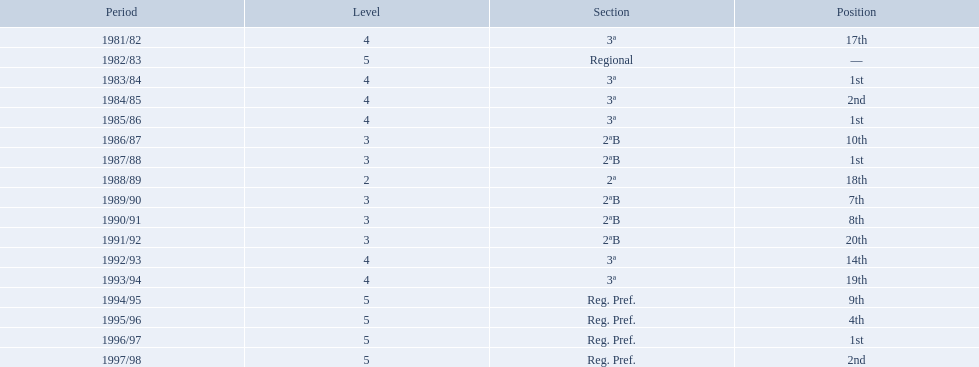Which years did the team have a season? 1981/82, 1982/83, 1983/84, 1984/85, 1985/86, 1986/87, 1987/88, 1988/89, 1989/90, 1990/91, 1991/92, 1992/93, 1993/94, 1994/95, 1995/96, 1996/97, 1997/98. Which of those years did the team place outside the top 10? 1981/82, 1988/89, 1991/92, 1992/93, 1993/94. Which of the years in which the team placed outside the top 10 did they have their worst performance? 1991/92. 